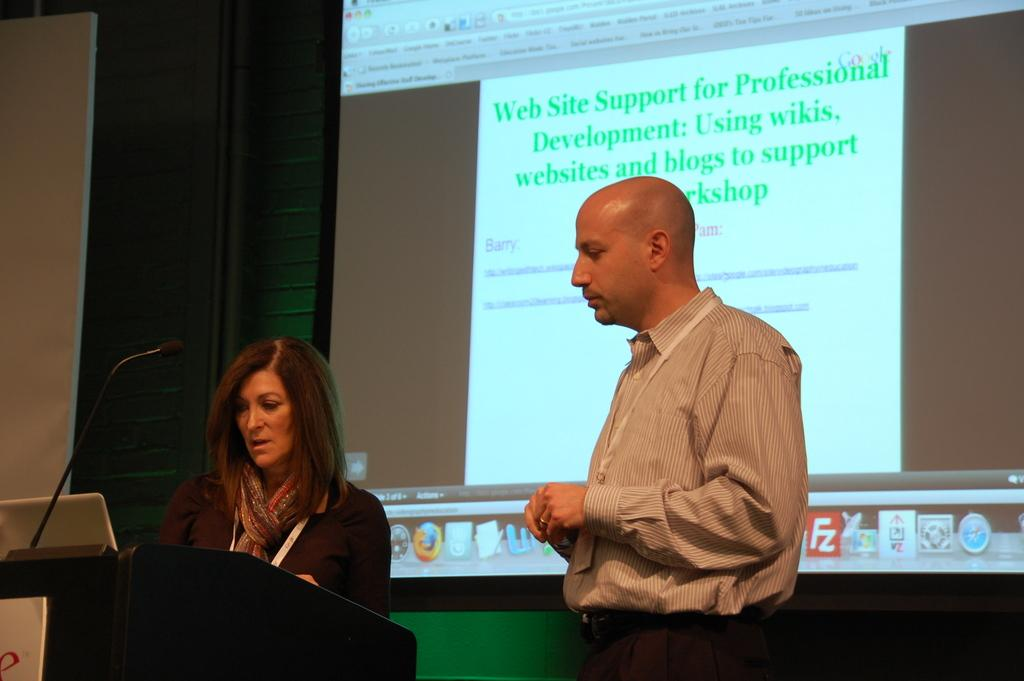What is the woman doing at the podium in the image? The woman is standing at the podium in the image. What items can be seen on the podium? A laptop and a microphone are present on the podium. What is the man doing in the image? The man is standing on the floor in the image. What type of visual aid is available in the image? There is a display screen in the image, which is associated with the podium. How much salt is on the podium in the image? There is no salt present on the podium in the image. What type of book is the man reading in the image? There is no book present in the image, and the man is not reading anything. 